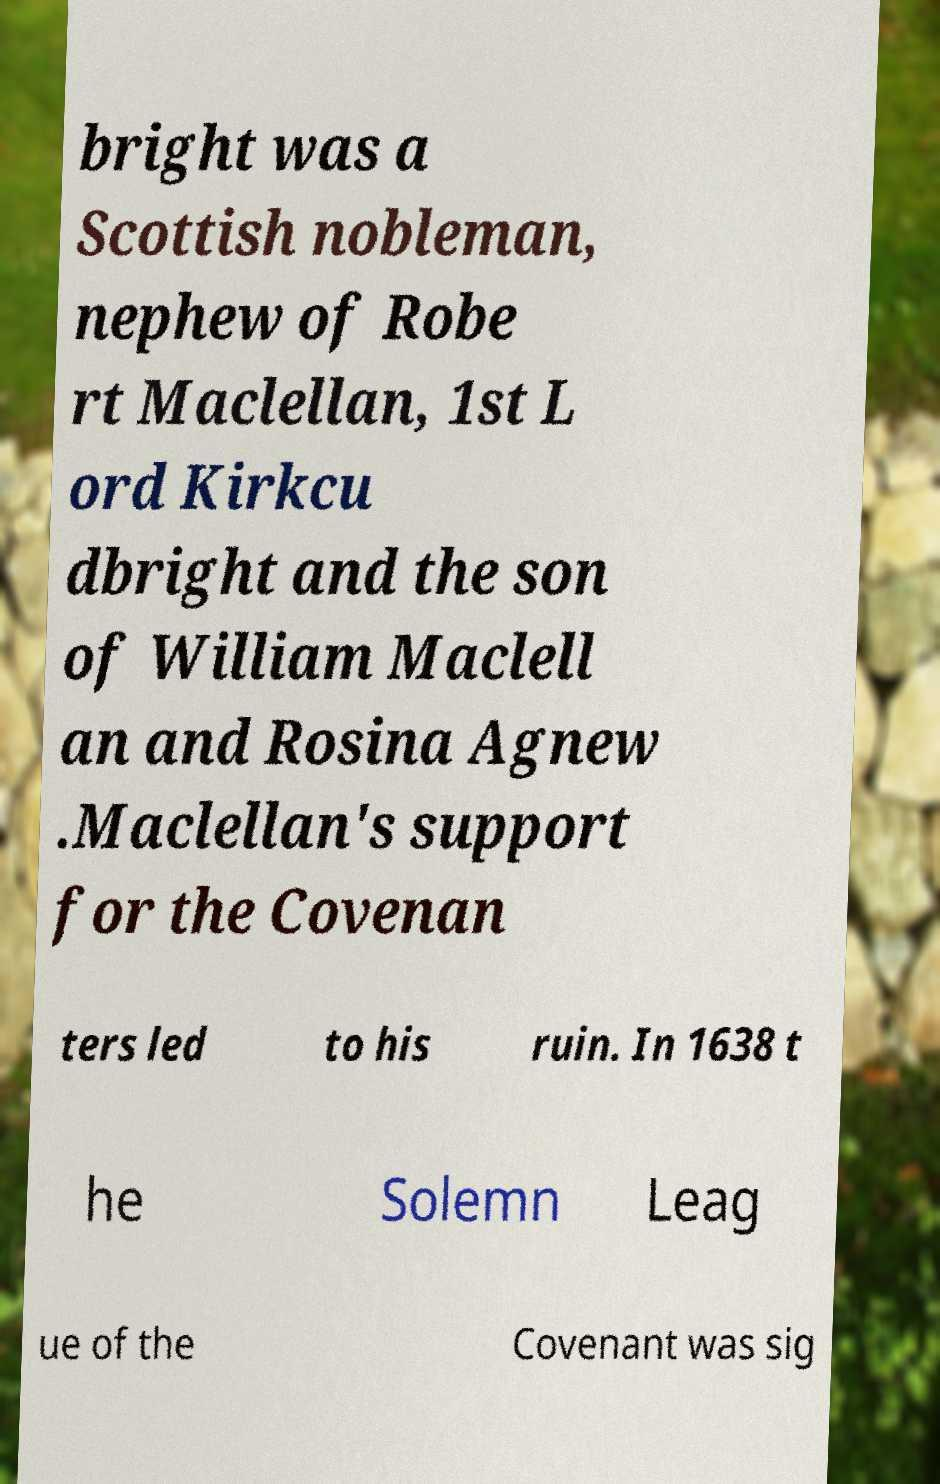Can you read and provide the text displayed in the image?This photo seems to have some interesting text. Can you extract and type it out for me? bright was a Scottish nobleman, nephew of Robe rt Maclellan, 1st L ord Kirkcu dbright and the son of William Maclell an and Rosina Agnew .Maclellan's support for the Covenan ters led to his ruin. In 1638 t he Solemn Leag ue of the Covenant was sig 